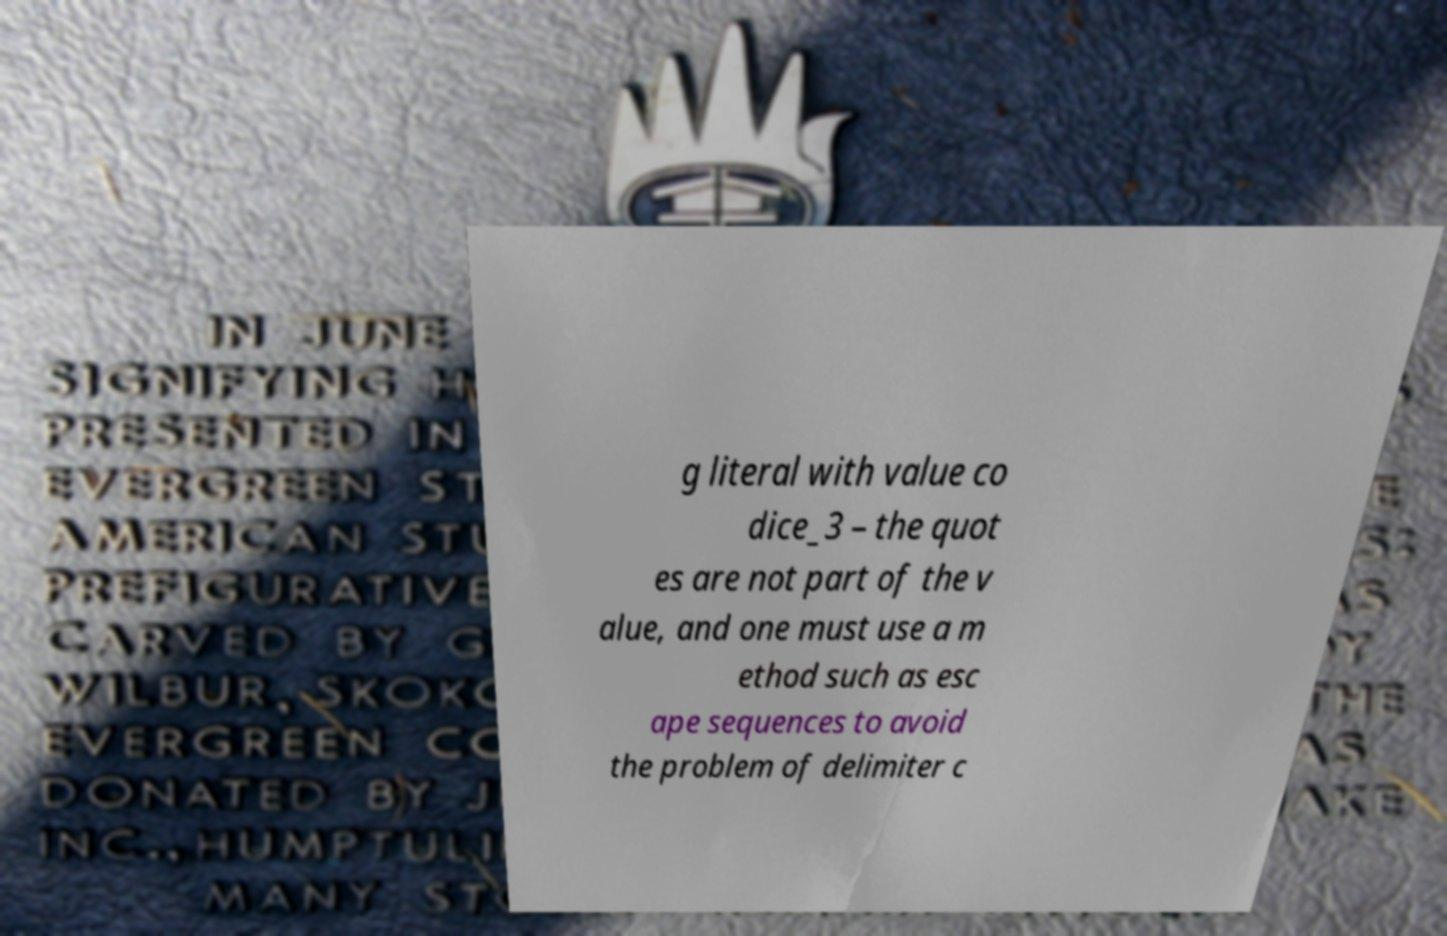Can you accurately transcribe the text from the provided image for me? g literal with value co dice_3 – the quot es are not part of the v alue, and one must use a m ethod such as esc ape sequences to avoid the problem of delimiter c 